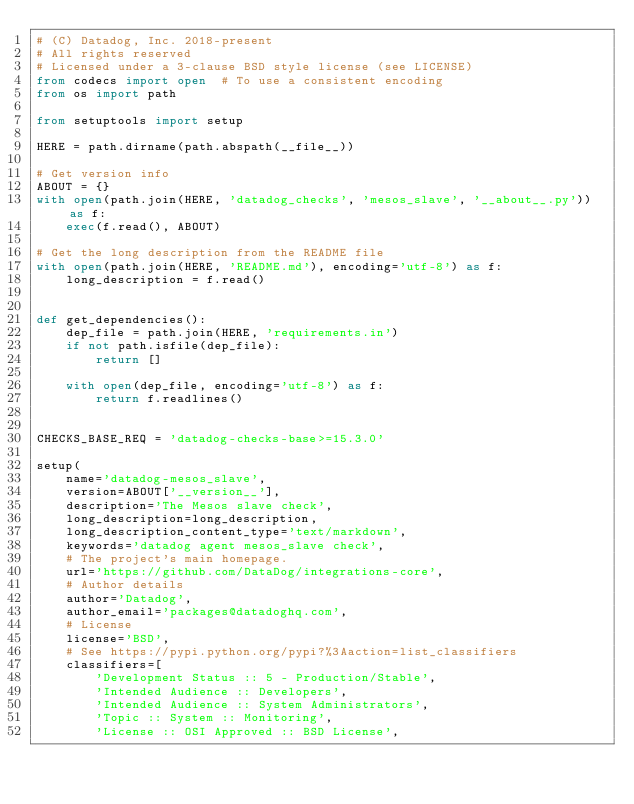<code> <loc_0><loc_0><loc_500><loc_500><_Python_># (C) Datadog, Inc. 2018-present
# All rights reserved
# Licensed under a 3-clause BSD style license (see LICENSE)
from codecs import open  # To use a consistent encoding
from os import path

from setuptools import setup

HERE = path.dirname(path.abspath(__file__))

# Get version info
ABOUT = {}
with open(path.join(HERE, 'datadog_checks', 'mesos_slave', '__about__.py')) as f:
    exec(f.read(), ABOUT)

# Get the long description from the README file
with open(path.join(HERE, 'README.md'), encoding='utf-8') as f:
    long_description = f.read()


def get_dependencies():
    dep_file = path.join(HERE, 'requirements.in')
    if not path.isfile(dep_file):
        return []

    with open(dep_file, encoding='utf-8') as f:
        return f.readlines()


CHECKS_BASE_REQ = 'datadog-checks-base>=15.3.0'

setup(
    name='datadog-mesos_slave',
    version=ABOUT['__version__'],
    description='The Mesos slave check',
    long_description=long_description,
    long_description_content_type='text/markdown',
    keywords='datadog agent mesos_slave check',
    # The project's main homepage.
    url='https://github.com/DataDog/integrations-core',
    # Author details
    author='Datadog',
    author_email='packages@datadoghq.com',
    # License
    license='BSD',
    # See https://pypi.python.org/pypi?%3Aaction=list_classifiers
    classifiers=[
        'Development Status :: 5 - Production/Stable',
        'Intended Audience :: Developers',
        'Intended Audience :: System Administrators',
        'Topic :: System :: Monitoring',
        'License :: OSI Approved :: BSD License',</code> 